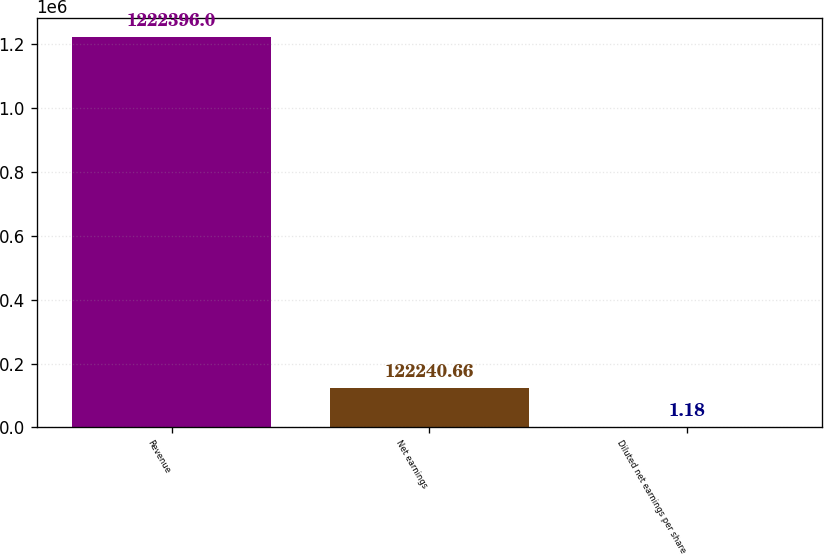Convert chart to OTSL. <chart><loc_0><loc_0><loc_500><loc_500><bar_chart><fcel>Revenue<fcel>Net earnings<fcel>Diluted net earnings per share<nl><fcel>1.2224e+06<fcel>122241<fcel>1.18<nl></chart> 